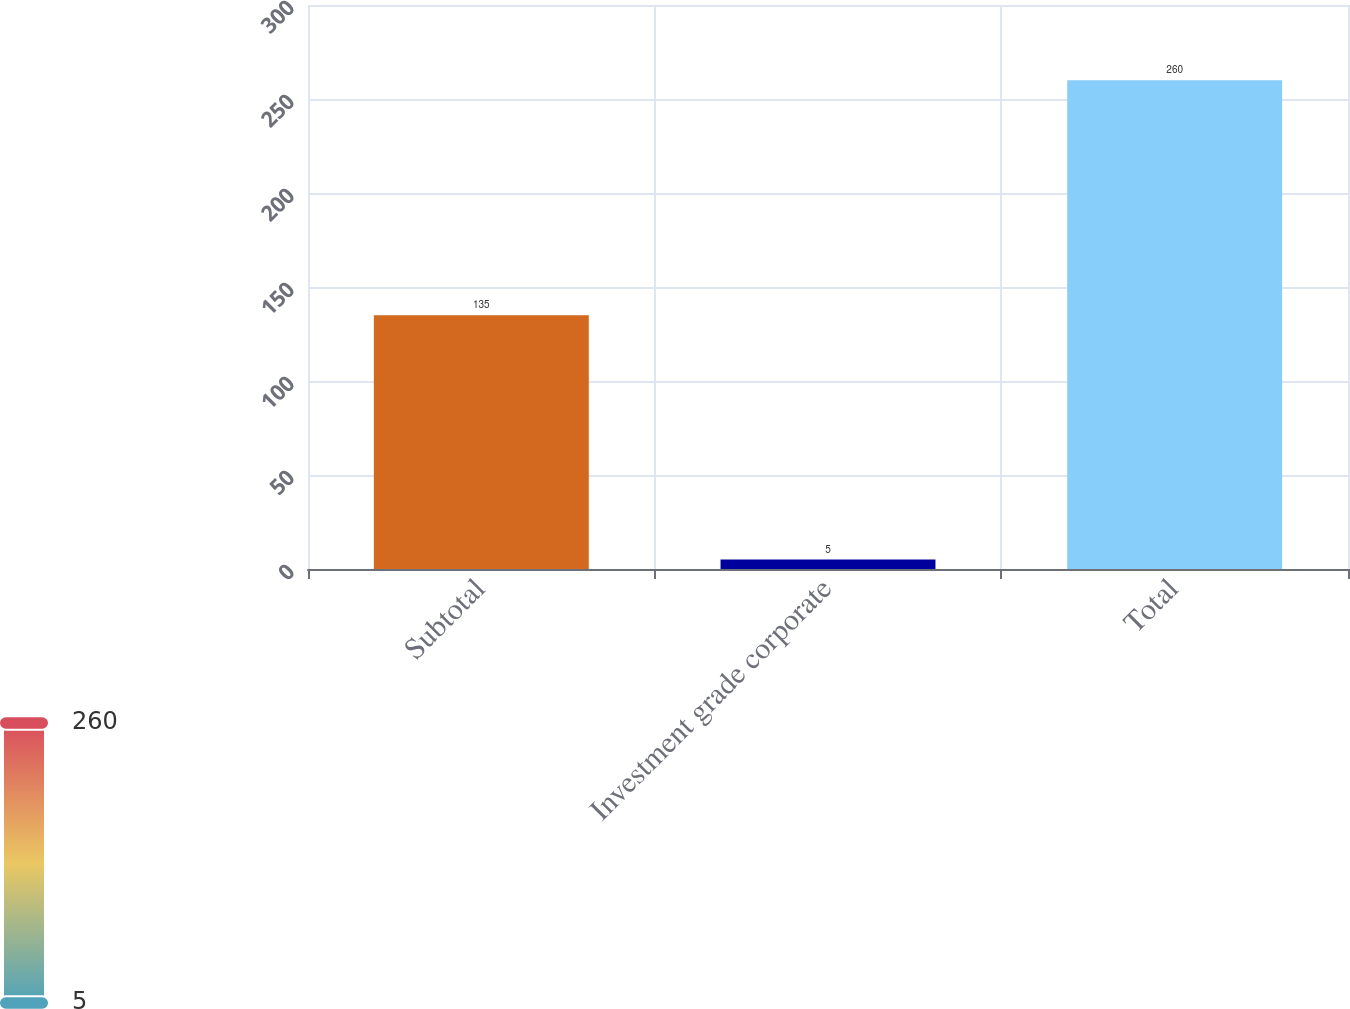Convert chart. <chart><loc_0><loc_0><loc_500><loc_500><bar_chart><fcel>Subtotal<fcel>Investment grade corporate<fcel>Total<nl><fcel>135<fcel>5<fcel>260<nl></chart> 